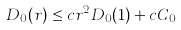<formula> <loc_0><loc_0><loc_500><loc_500>D _ { 0 } ( r ) \leq c r ^ { 2 } D _ { 0 } ( 1 ) + c C _ { 0 }</formula> 